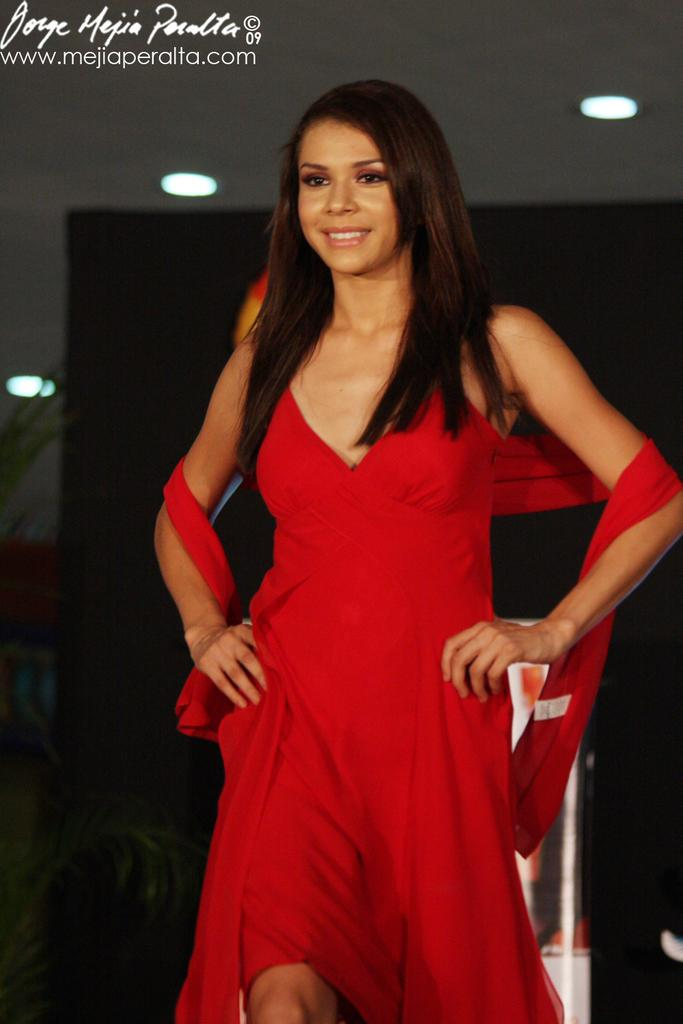Who is present in the image? There is a woman in the image. What can be seen in the background of the image? There are lights in the background of the image. Is there any text or logo visible in the image? Yes, there is a watermark in the top left corner of the image. What type of canvas is the woman painting on in the image? There is no canvas or painting activity present in the image. 